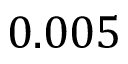<formula> <loc_0><loc_0><loc_500><loc_500>0 . 0 0 5</formula> 